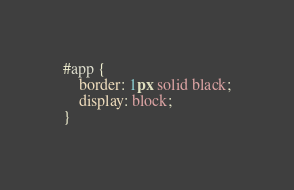Convert code to text. <code><loc_0><loc_0><loc_500><loc_500><_CSS_>#app {
    border: 1px solid black;
    display: block;
}</code> 